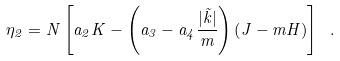<formula> <loc_0><loc_0><loc_500><loc_500>\eta _ { 2 } = N \left [ a _ { 2 } K - \left ( a _ { 3 } - a _ { 4 } \frac { | \vec { k } | } { m } \right ) \left ( J - m H \right ) \right ] \ .</formula> 